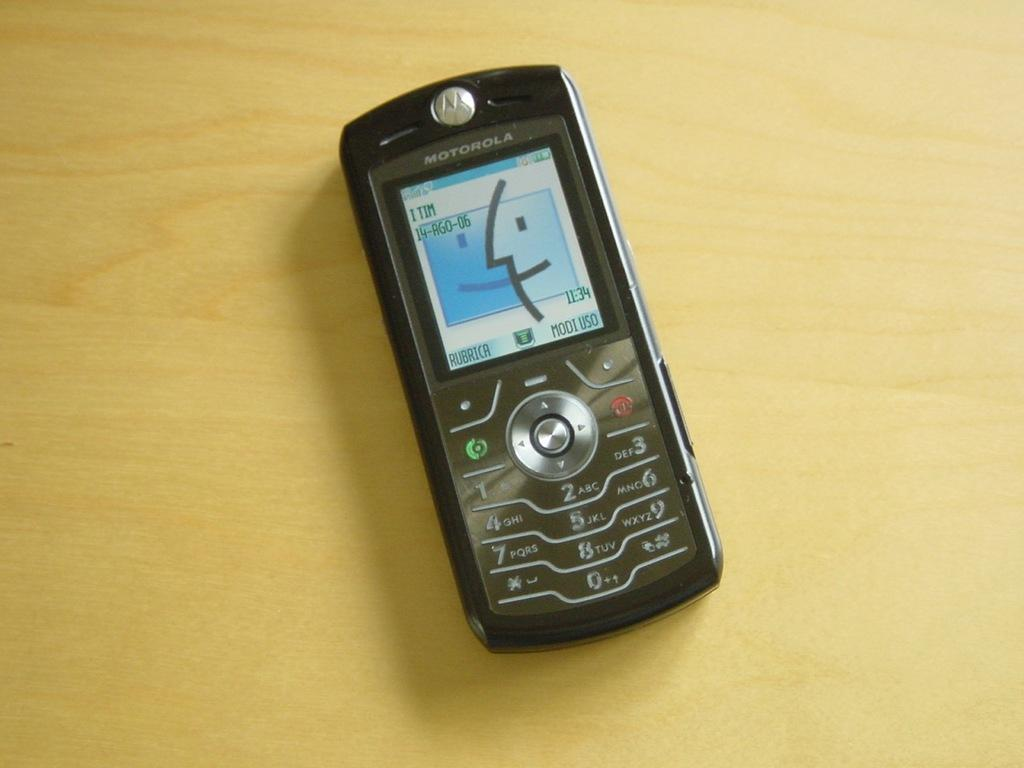Provide a one-sentence caption for the provided image. an old black motorola cell phone sits on the counter. 